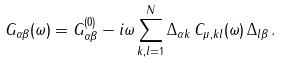<formula> <loc_0><loc_0><loc_500><loc_500>G _ { \alpha \beta } ( \omega ) = G _ { \alpha \beta } ^ { ( 0 ) } - i \omega \sum _ { k , l = 1 } ^ { N } \Delta _ { \alpha k } \, C _ { \mu , k l } ( \omega ) \, \Delta _ { l \beta } \, .</formula> 